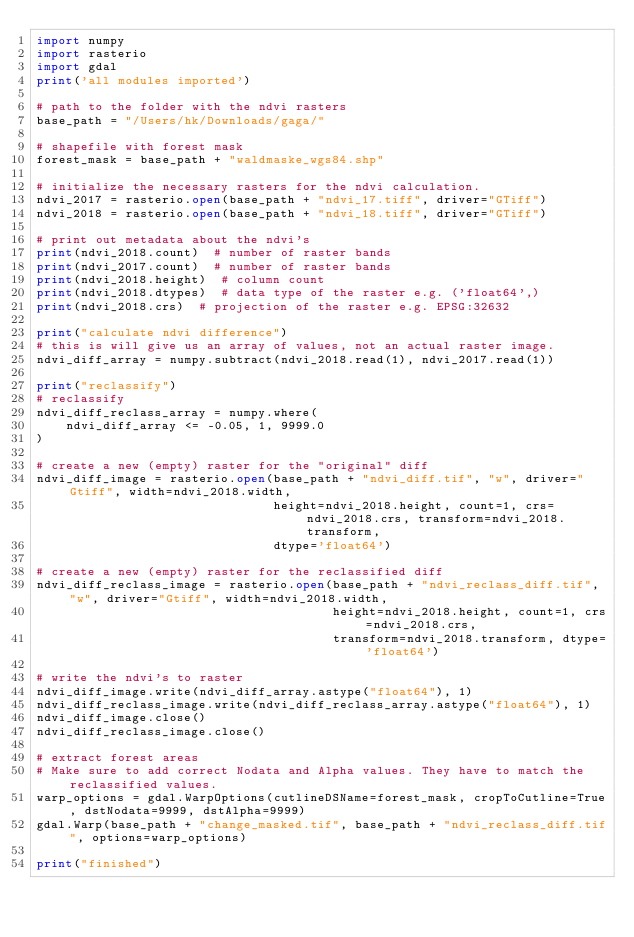Convert code to text. <code><loc_0><loc_0><loc_500><loc_500><_Python_>import numpy
import rasterio
import gdal
print('all modules imported')

# path to the folder with the ndvi rasters
base_path = "/Users/hk/Downloads/gaga/"

# shapefile with forest mask
forest_mask = base_path + "waldmaske_wgs84.shp"

# initialize the necessary rasters for the ndvi calculation.
ndvi_2017 = rasterio.open(base_path + "ndvi_17.tiff", driver="GTiff")
ndvi_2018 = rasterio.open(base_path + "ndvi_18.tiff", driver="GTiff")

# print out metadata about the ndvi's
print(ndvi_2018.count)  # number of raster bands
print(ndvi_2017.count)  # number of raster bands
print(ndvi_2018.height)  # column count
print(ndvi_2018.dtypes)  # data type of the raster e.g. ('float64',)
print(ndvi_2018.crs)  # projection of the raster e.g. EPSG:32632

print("calculate ndvi difference")
# this is will give us an array of values, not an actual raster image.
ndvi_diff_array = numpy.subtract(ndvi_2018.read(1), ndvi_2017.read(1))

print("reclassify")
# reclassify
ndvi_diff_reclass_array = numpy.where(
    ndvi_diff_array <= -0.05, 1, 9999.0
)

# create a new (empty) raster for the "original" diff
ndvi_diff_image = rasterio.open(base_path + "ndvi_diff.tif", "w", driver="Gtiff", width=ndvi_2018.width,
                                height=ndvi_2018.height, count=1, crs=ndvi_2018.crs, transform=ndvi_2018.transform,
                                dtype='float64')

# create a new (empty) raster for the reclassified diff
ndvi_diff_reclass_image = rasterio.open(base_path + "ndvi_reclass_diff.tif", "w", driver="Gtiff", width=ndvi_2018.width,
                                        height=ndvi_2018.height, count=1, crs=ndvi_2018.crs,
                                        transform=ndvi_2018.transform, dtype='float64')

# write the ndvi's to raster
ndvi_diff_image.write(ndvi_diff_array.astype("float64"), 1)
ndvi_diff_reclass_image.write(ndvi_diff_reclass_array.astype("float64"), 1)
ndvi_diff_image.close()
ndvi_diff_reclass_image.close()

# extract forest areas
# Make sure to add correct Nodata and Alpha values. They have to match the reclassified values.
warp_options = gdal.WarpOptions(cutlineDSName=forest_mask, cropToCutline=True, dstNodata=9999, dstAlpha=9999)
gdal.Warp(base_path + "change_masked.tif", base_path + "ndvi_reclass_diff.tif", options=warp_options)

print("finished")
</code> 